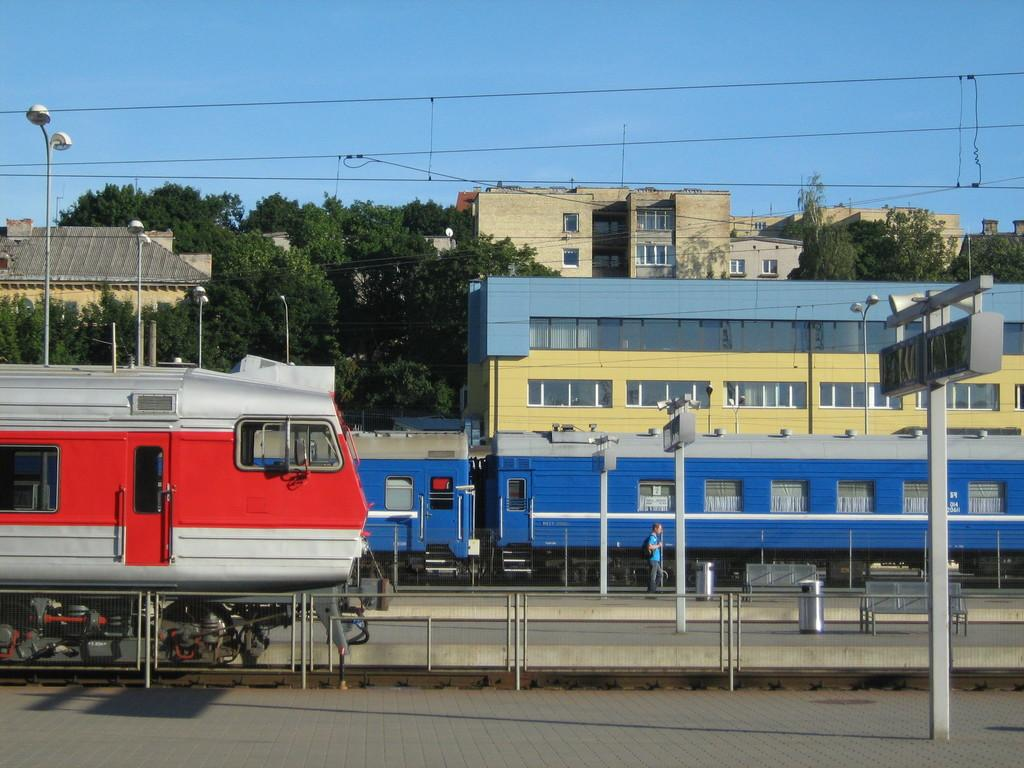What type of vehicles can be seen in the image? There are trains in the image. What structures are present in the image? There are poles, rods, and platforms in the image. Can you describe the person in the image? A person is standing in the image. What can be seen in the background of the image? There are trees, buildings, street lights, wires, and the sky visible in the background of the image. What is the chance of winning the lottery in the image? There is no mention of a lottery or any chance of winning in the image. What type of clock is present in the image? There is no clock visible in the image. 